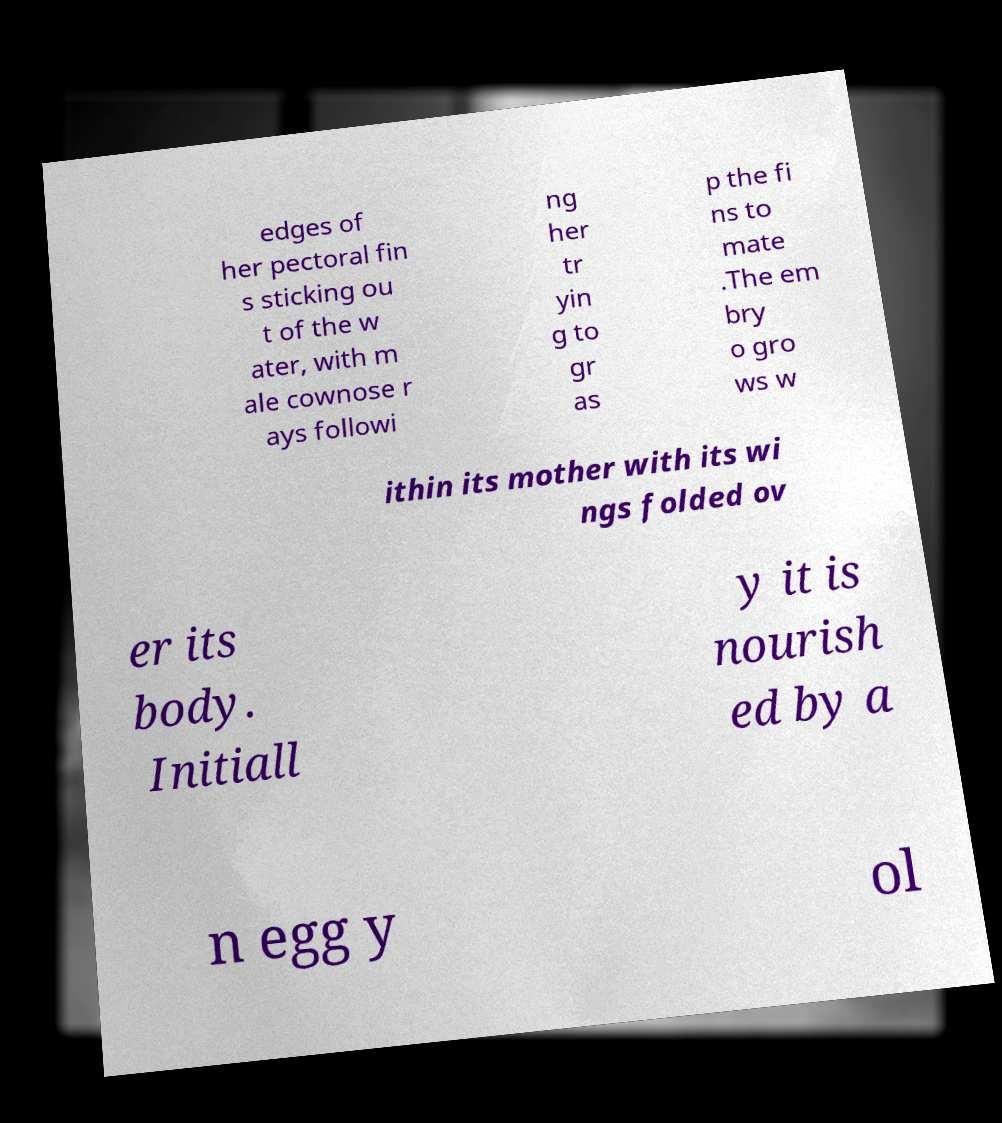What messages or text are displayed in this image? I need them in a readable, typed format. edges of her pectoral fin s sticking ou t of the w ater, with m ale cownose r ays followi ng her tr yin g to gr as p the fi ns to mate .The em bry o gro ws w ithin its mother with its wi ngs folded ov er its body. Initiall y it is nourish ed by a n egg y ol 